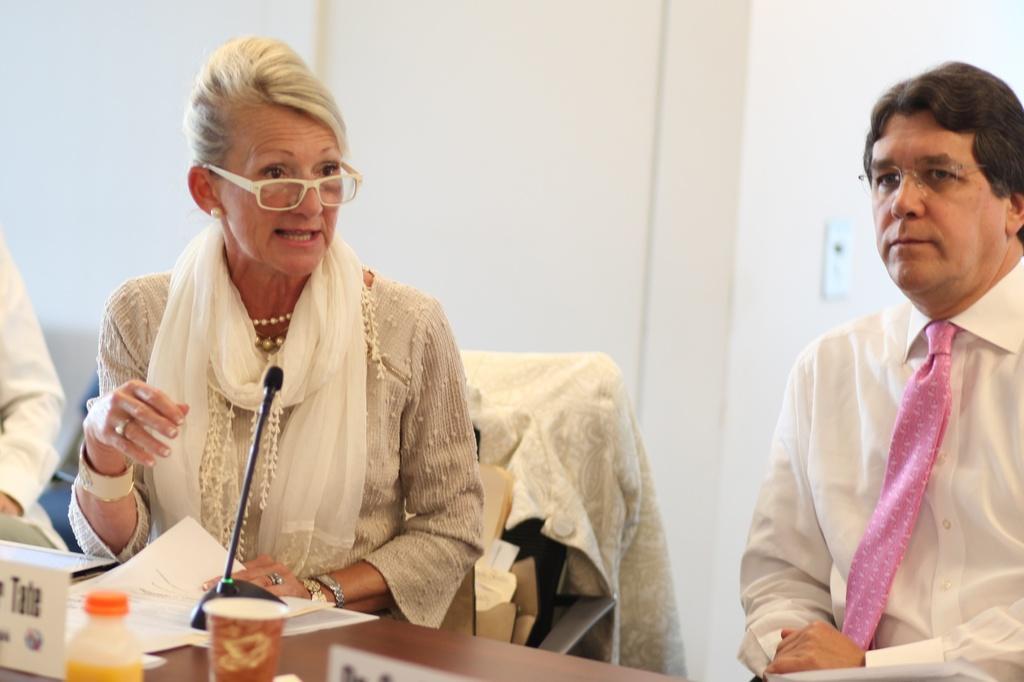Can you describe this image briefly? This picture seems to be clicked inside the room. On the right corner we can see a person wearing white color shirt, pink color tie and sitting. On the left we can see a woman wearing a dress, spectacles, sitting on the chair and holding a paper and seems to be talking. In the foreground we can see a wooden table on the top of which bottle, glass, papers, microphone and some other objects are placed. In the background we can see the wall and some other objects. On the left corner we can see a person. 